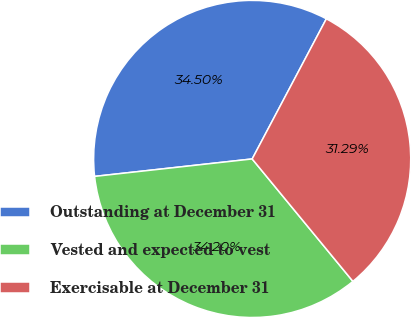Convert chart to OTSL. <chart><loc_0><loc_0><loc_500><loc_500><pie_chart><fcel>Outstanding at December 31<fcel>Vested and expected to vest<fcel>Exercisable at December 31<nl><fcel>34.5%<fcel>34.2%<fcel>31.29%<nl></chart> 